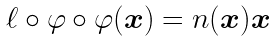<formula> <loc_0><loc_0><loc_500><loc_500>\ell \circ \varphi \circ \varphi ( { \boldsymbol x } ) = n ( { \boldsymbol x } ) { \boldsymbol x }</formula> 